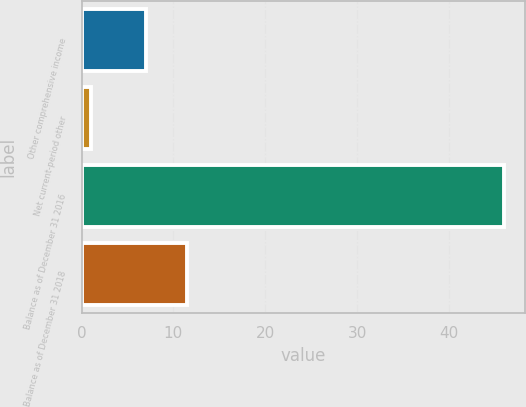Convert chart to OTSL. <chart><loc_0><loc_0><loc_500><loc_500><bar_chart><fcel>Other comprehensive income<fcel>Net current-period other<fcel>Balance as of December 31 2016<fcel>Balance as of December 31 2018<nl><fcel>7<fcel>1<fcel>46<fcel>11.5<nl></chart> 